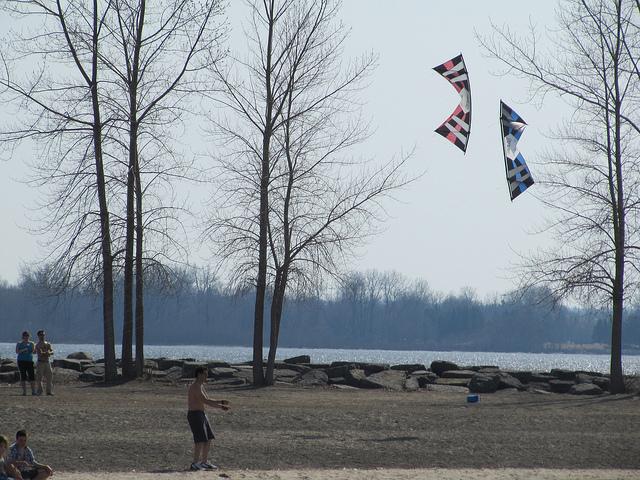Is there snow on the ground?
Give a very brief answer. No. Is the kite stuck in the tree?
Short answer required. No. Is this a residential area?
Give a very brief answer. No. Is it snowing?
Give a very brief answer. No. What season was this photo likely taken in?
Keep it brief. Summer. What season is it in this picture?
Write a very short answer. Summer. How many kites are in the image?
Give a very brief answer. 2. What type of weather day would this be?
Short answer required. Cloudy. What color are the kites?
Short answer required. Red and blue. Is it cold here?
Write a very short answer. No. Is this in an intersection?
Give a very brief answer. No. What time of year is it?
Answer briefly. Fall. Is the boy flying the kites wearing a shirt?
Keep it brief. No. Can you walk through this?
Concise answer only. Yes. Is it cold outside?
Keep it brief. No. Does any part of this area light up at night?
Give a very brief answer. No. 